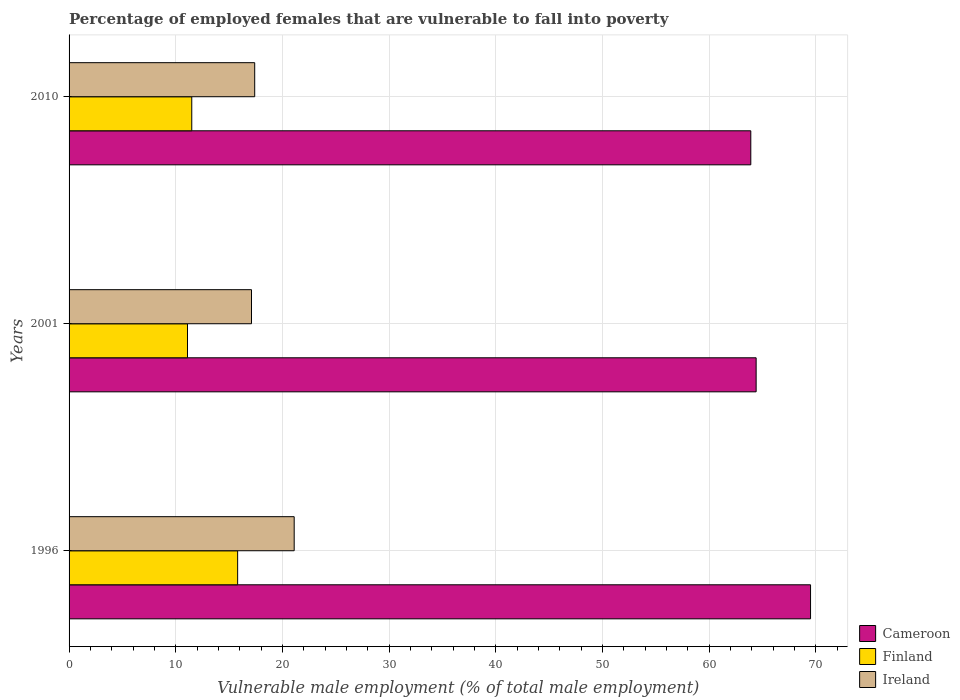How many bars are there on the 3rd tick from the bottom?
Provide a short and direct response. 3. What is the label of the 1st group of bars from the top?
Offer a terse response. 2010. What is the percentage of employed females who are vulnerable to fall into poverty in Cameroon in 2001?
Offer a terse response. 64.4. Across all years, what is the maximum percentage of employed females who are vulnerable to fall into poverty in Finland?
Provide a succinct answer. 15.8. Across all years, what is the minimum percentage of employed females who are vulnerable to fall into poverty in Cameroon?
Your answer should be compact. 63.9. In which year was the percentage of employed females who are vulnerable to fall into poverty in Ireland minimum?
Your response must be concise. 2001. What is the total percentage of employed females who are vulnerable to fall into poverty in Finland in the graph?
Offer a terse response. 38.4. What is the difference between the percentage of employed females who are vulnerable to fall into poverty in Finland in 1996 and that in 2010?
Ensure brevity in your answer.  4.3. What is the difference between the percentage of employed females who are vulnerable to fall into poverty in Ireland in 2010 and the percentage of employed females who are vulnerable to fall into poverty in Cameroon in 2001?
Offer a very short reply. -47. What is the average percentage of employed females who are vulnerable to fall into poverty in Finland per year?
Give a very brief answer. 12.8. In the year 2010, what is the difference between the percentage of employed females who are vulnerable to fall into poverty in Ireland and percentage of employed females who are vulnerable to fall into poverty in Cameroon?
Your response must be concise. -46.5. What is the ratio of the percentage of employed females who are vulnerable to fall into poverty in Finland in 1996 to that in 2010?
Give a very brief answer. 1.37. Is the percentage of employed females who are vulnerable to fall into poverty in Ireland in 2001 less than that in 2010?
Provide a succinct answer. Yes. Is the difference between the percentage of employed females who are vulnerable to fall into poverty in Ireland in 2001 and 2010 greater than the difference between the percentage of employed females who are vulnerable to fall into poverty in Cameroon in 2001 and 2010?
Provide a short and direct response. No. What is the difference between the highest and the second highest percentage of employed females who are vulnerable to fall into poverty in Cameroon?
Give a very brief answer. 5.1. What is the difference between the highest and the lowest percentage of employed females who are vulnerable to fall into poverty in Finland?
Your answer should be compact. 4.7. What does the 1st bar from the top in 2010 represents?
Provide a succinct answer. Ireland. What does the 3rd bar from the bottom in 2001 represents?
Keep it short and to the point. Ireland. Is it the case that in every year, the sum of the percentage of employed females who are vulnerable to fall into poverty in Cameroon and percentage of employed females who are vulnerable to fall into poverty in Ireland is greater than the percentage of employed females who are vulnerable to fall into poverty in Finland?
Your response must be concise. Yes. How many bars are there?
Ensure brevity in your answer.  9. Are all the bars in the graph horizontal?
Give a very brief answer. Yes. How many years are there in the graph?
Keep it short and to the point. 3. What is the difference between two consecutive major ticks on the X-axis?
Your answer should be very brief. 10. Are the values on the major ticks of X-axis written in scientific E-notation?
Make the answer very short. No. Does the graph contain grids?
Your answer should be very brief. Yes. Where does the legend appear in the graph?
Ensure brevity in your answer.  Bottom right. How many legend labels are there?
Make the answer very short. 3. How are the legend labels stacked?
Your answer should be compact. Vertical. What is the title of the graph?
Your response must be concise. Percentage of employed females that are vulnerable to fall into poverty. Does "Germany" appear as one of the legend labels in the graph?
Ensure brevity in your answer.  No. What is the label or title of the X-axis?
Offer a very short reply. Vulnerable male employment (% of total male employment). What is the Vulnerable male employment (% of total male employment) in Cameroon in 1996?
Ensure brevity in your answer.  69.5. What is the Vulnerable male employment (% of total male employment) in Finland in 1996?
Offer a terse response. 15.8. What is the Vulnerable male employment (% of total male employment) in Ireland in 1996?
Ensure brevity in your answer.  21.1. What is the Vulnerable male employment (% of total male employment) in Cameroon in 2001?
Give a very brief answer. 64.4. What is the Vulnerable male employment (% of total male employment) in Finland in 2001?
Your answer should be very brief. 11.1. What is the Vulnerable male employment (% of total male employment) in Ireland in 2001?
Offer a terse response. 17.1. What is the Vulnerable male employment (% of total male employment) in Cameroon in 2010?
Your answer should be very brief. 63.9. What is the Vulnerable male employment (% of total male employment) of Finland in 2010?
Make the answer very short. 11.5. What is the Vulnerable male employment (% of total male employment) in Ireland in 2010?
Provide a succinct answer. 17.4. Across all years, what is the maximum Vulnerable male employment (% of total male employment) in Cameroon?
Keep it short and to the point. 69.5. Across all years, what is the maximum Vulnerable male employment (% of total male employment) in Finland?
Make the answer very short. 15.8. Across all years, what is the maximum Vulnerable male employment (% of total male employment) of Ireland?
Provide a short and direct response. 21.1. Across all years, what is the minimum Vulnerable male employment (% of total male employment) of Cameroon?
Make the answer very short. 63.9. Across all years, what is the minimum Vulnerable male employment (% of total male employment) in Finland?
Offer a terse response. 11.1. Across all years, what is the minimum Vulnerable male employment (% of total male employment) in Ireland?
Provide a succinct answer. 17.1. What is the total Vulnerable male employment (% of total male employment) of Cameroon in the graph?
Give a very brief answer. 197.8. What is the total Vulnerable male employment (% of total male employment) in Finland in the graph?
Offer a very short reply. 38.4. What is the total Vulnerable male employment (% of total male employment) of Ireland in the graph?
Your answer should be very brief. 55.6. What is the difference between the Vulnerable male employment (% of total male employment) of Cameroon in 1996 and that in 2001?
Your answer should be compact. 5.1. What is the difference between the Vulnerable male employment (% of total male employment) of Finland in 1996 and that in 2001?
Offer a very short reply. 4.7. What is the difference between the Vulnerable male employment (% of total male employment) in Ireland in 1996 and that in 2001?
Offer a terse response. 4. What is the difference between the Vulnerable male employment (% of total male employment) in Finland in 1996 and that in 2010?
Your response must be concise. 4.3. What is the difference between the Vulnerable male employment (% of total male employment) of Finland in 2001 and that in 2010?
Keep it short and to the point. -0.4. What is the difference between the Vulnerable male employment (% of total male employment) of Ireland in 2001 and that in 2010?
Your answer should be compact. -0.3. What is the difference between the Vulnerable male employment (% of total male employment) of Cameroon in 1996 and the Vulnerable male employment (% of total male employment) of Finland in 2001?
Provide a short and direct response. 58.4. What is the difference between the Vulnerable male employment (% of total male employment) in Cameroon in 1996 and the Vulnerable male employment (% of total male employment) in Ireland in 2001?
Provide a succinct answer. 52.4. What is the difference between the Vulnerable male employment (% of total male employment) of Finland in 1996 and the Vulnerable male employment (% of total male employment) of Ireland in 2001?
Provide a succinct answer. -1.3. What is the difference between the Vulnerable male employment (% of total male employment) of Cameroon in 1996 and the Vulnerable male employment (% of total male employment) of Finland in 2010?
Your response must be concise. 58. What is the difference between the Vulnerable male employment (% of total male employment) in Cameroon in 1996 and the Vulnerable male employment (% of total male employment) in Ireland in 2010?
Your answer should be very brief. 52.1. What is the difference between the Vulnerable male employment (% of total male employment) in Cameroon in 2001 and the Vulnerable male employment (% of total male employment) in Finland in 2010?
Offer a terse response. 52.9. What is the difference between the Vulnerable male employment (% of total male employment) in Cameroon in 2001 and the Vulnerable male employment (% of total male employment) in Ireland in 2010?
Provide a succinct answer. 47. What is the difference between the Vulnerable male employment (% of total male employment) of Finland in 2001 and the Vulnerable male employment (% of total male employment) of Ireland in 2010?
Provide a short and direct response. -6.3. What is the average Vulnerable male employment (% of total male employment) of Cameroon per year?
Give a very brief answer. 65.93. What is the average Vulnerable male employment (% of total male employment) of Finland per year?
Give a very brief answer. 12.8. What is the average Vulnerable male employment (% of total male employment) in Ireland per year?
Keep it short and to the point. 18.53. In the year 1996, what is the difference between the Vulnerable male employment (% of total male employment) in Cameroon and Vulnerable male employment (% of total male employment) in Finland?
Ensure brevity in your answer.  53.7. In the year 1996, what is the difference between the Vulnerable male employment (% of total male employment) in Cameroon and Vulnerable male employment (% of total male employment) in Ireland?
Make the answer very short. 48.4. In the year 1996, what is the difference between the Vulnerable male employment (% of total male employment) in Finland and Vulnerable male employment (% of total male employment) in Ireland?
Make the answer very short. -5.3. In the year 2001, what is the difference between the Vulnerable male employment (% of total male employment) of Cameroon and Vulnerable male employment (% of total male employment) of Finland?
Give a very brief answer. 53.3. In the year 2001, what is the difference between the Vulnerable male employment (% of total male employment) of Cameroon and Vulnerable male employment (% of total male employment) of Ireland?
Your response must be concise. 47.3. In the year 2010, what is the difference between the Vulnerable male employment (% of total male employment) in Cameroon and Vulnerable male employment (% of total male employment) in Finland?
Your answer should be compact. 52.4. In the year 2010, what is the difference between the Vulnerable male employment (% of total male employment) in Cameroon and Vulnerable male employment (% of total male employment) in Ireland?
Offer a terse response. 46.5. In the year 2010, what is the difference between the Vulnerable male employment (% of total male employment) in Finland and Vulnerable male employment (% of total male employment) in Ireland?
Ensure brevity in your answer.  -5.9. What is the ratio of the Vulnerable male employment (% of total male employment) in Cameroon in 1996 to that in 2001?
Your answer should be compact. 1.08. What is the ratio of the Vulnerable male employment (% of total male employment) of Finland in 1996 to that in 2001?
Offer a very short reply. 1.42. What is the ratio of the Vulnerable male employment (% of total male employment) in Ireland in 1996 to that in 2001?
Keep it short and to the point. 1.23. What is the ratio of the Vulnerable male employment (% of total male employment) in Cameroon in 1996 to that in 2010?
Keep it short and to the point. 1.09. What is the ratio of the Vulnerable male employment (% of total male employment) of Finland in 1996 to that in 2010?
Keep it short and to the point. 1.37. What is the ratio of the Vulnerable male employment (% of total male employment) of Ireland in 1996 to that in 2010?
Your answer should be very brief. 1.21. What is the ratio of the Vulnerable male employment (% of total male employment) in Cameroon in 2001 to that in 2010?
Ensure brevity in your answer.  1.01. What is the ratio of the Vulnerable male employment (% of total male employment) in Finland in 2001 to that in 2010?
Ensure brevity in your answer.  0.97. What is the ratio of the Vulnerable male employment (% of total male employment) in Ireland in 2001 to that in 2010?
Give a very brief answer. 0.98. 